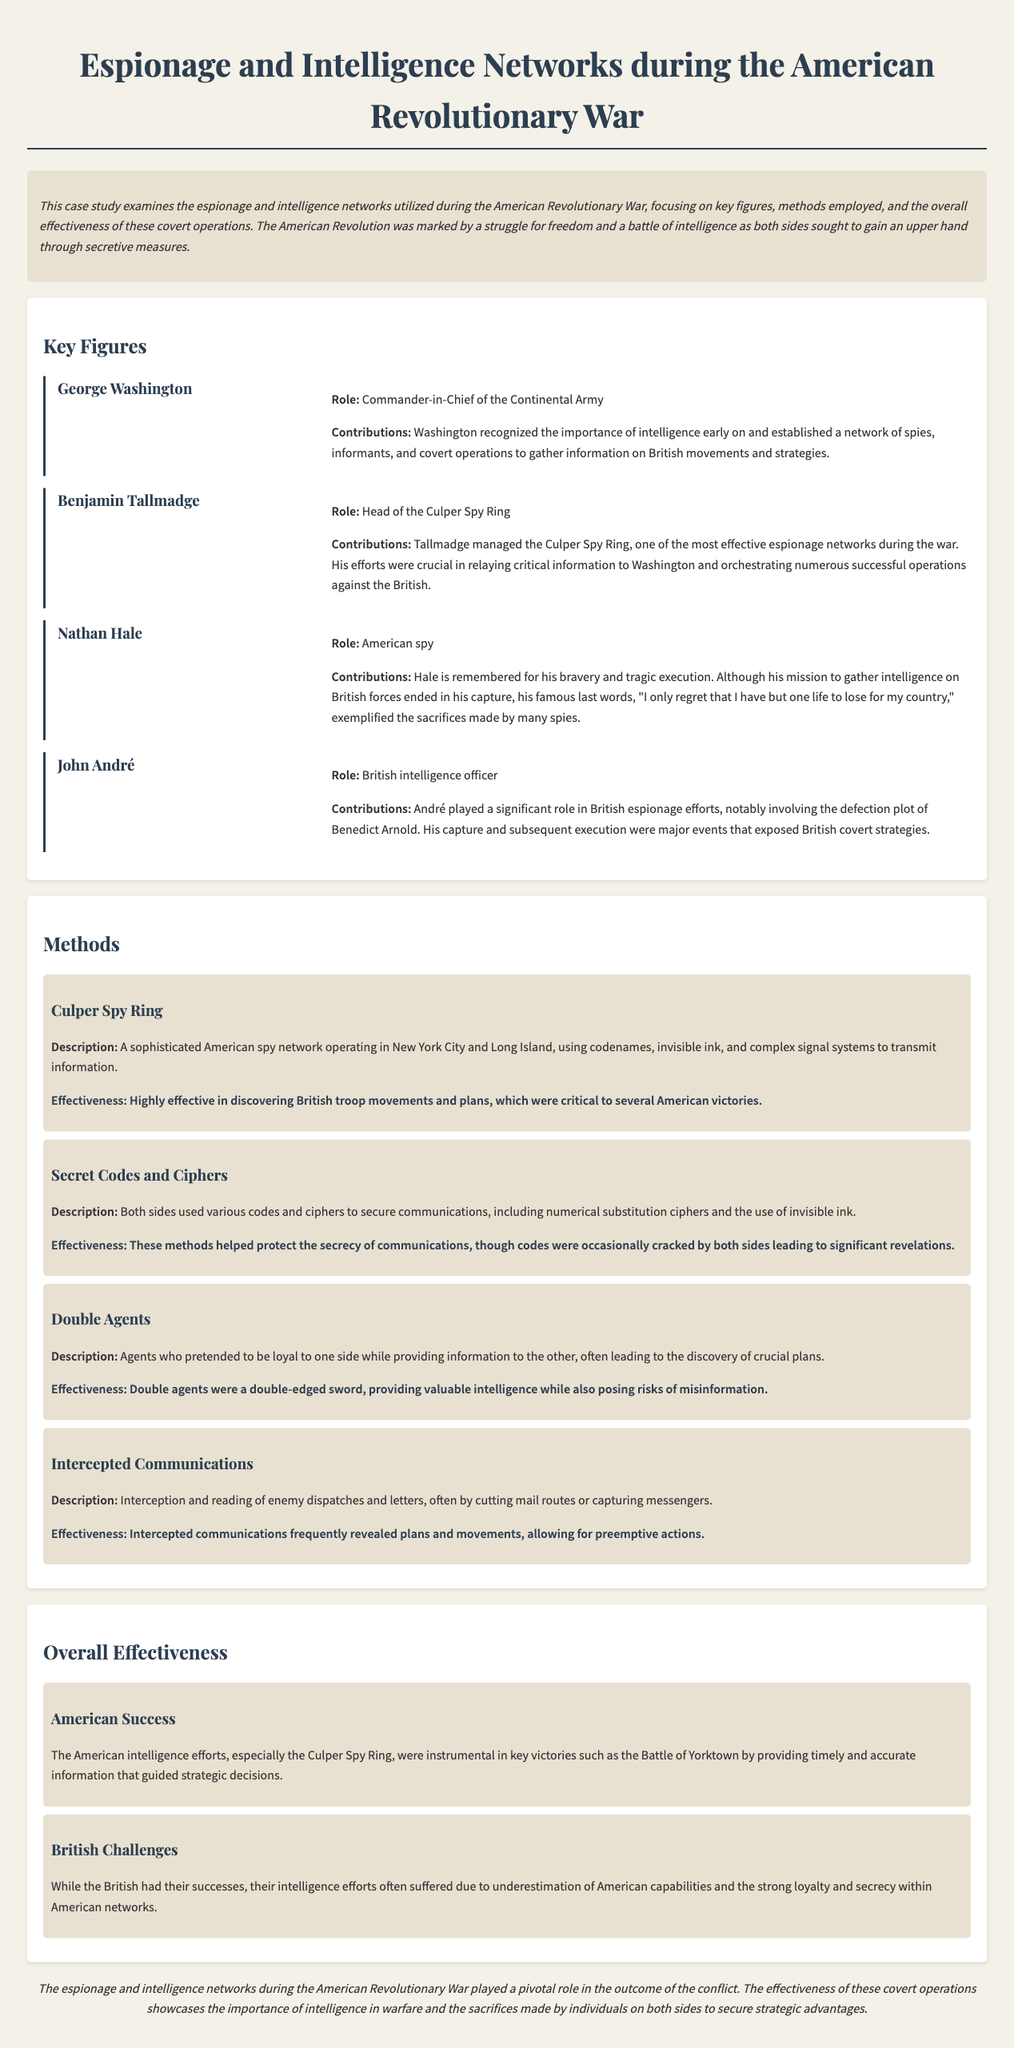What was George Washington's role? George Washington served as the Commander-in-Chief of the Continental Army during the American Revolutionary War.
Answer: Commander-in-Chief of the Continental Army Who headed the Culper Spy Ring? The document states that Benjamin Tallmadge was the head of the Culper Spy Ring, an effective espionage network.
Answer: Benjamin Tallmadge What were Nathan Hale's famous last words? Nathan Hale is remembered for saying, "I only regret that I have but one life to lose for my country."
Answer: "I only regret that I have but one life to lose for my country." What was a significant event involving John André? André's capture and subsequent execution were major events that exposed British covert strategies.
Answer: Capture and execution What method did the Culper Spy Ring use? The Culper Spy Ring used codenames, invisible ink, and complex signal systems to transmit information.
Answer: Codenames, invisible ink, and complex signal systems How effective was the intercepted communications method? Intercepted communications frequently revealed plans and movements, allowing for preemptive actions, highlighting its effectiveness.
Answer: Frequently revealed plans and movements What was a conclusion on American intelligence efforts? The case study concludes that the American intelligence efforts, especially the Culper Spy Ring, were instrumental in key victories.
Answer: Instrumental in key victories What were British challenges in their intelligence efforts? British intelligence efforts often suffered due to underestimation of American capabilities and the strong loyalty within American networks.
Answer: Underestimation of American capabilities What was a key factor for American success according to the document? The American intelligence efforts provided timely and accurate information, critical for strategic decisions and victories.
Answer: Timely and accurate information 